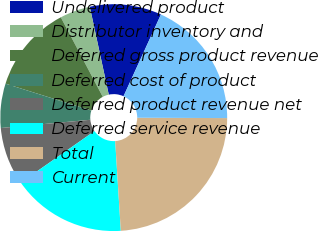Convert chart. <chart><loc_0><loc_0><loc_500><loc_500><pie_chart><fcel>Undelivered product<fcel>Distributor inventory and<fcel>Deferred gross product revenue<fcel>Deferred cost of product<fcel>Deferred product revenue net<fcel>Deferred service revenue<fcel>Total<fcel>Current<nl><fcel>10.22%<fcel>4.34%<fcel>12.43%<fcel>6.3%<fcel>8.26%<fcel>16.27%<fcel>23.94%<fcel>18.23%<nl></chart> 